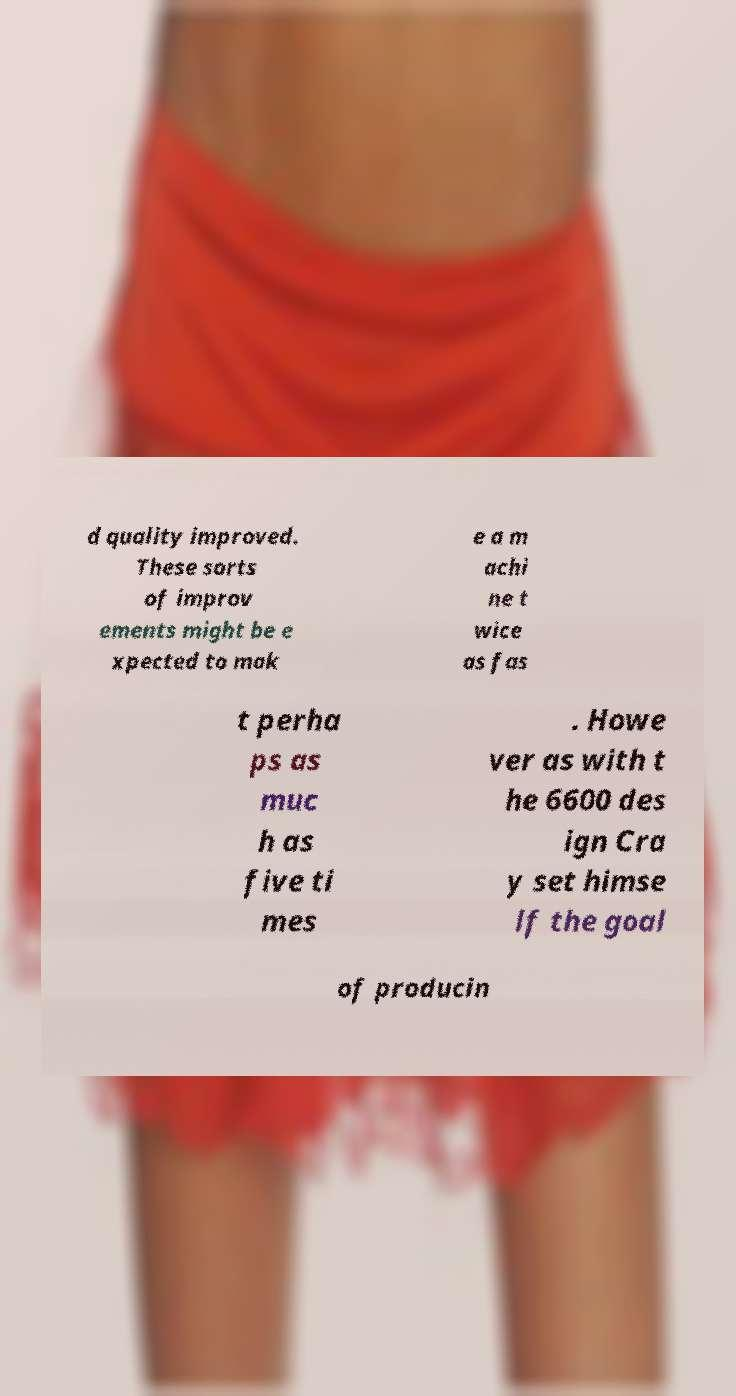I need the written content from this picture converted into text. Can you do that? d quality improved. These sorts of improv ements might be e xpected to mak e a m achi ne t wice as fas t perha ps as muc h as five ti mes . Howe ver as with t he 6600 des ign Cra y set himse lf the goal of producin 